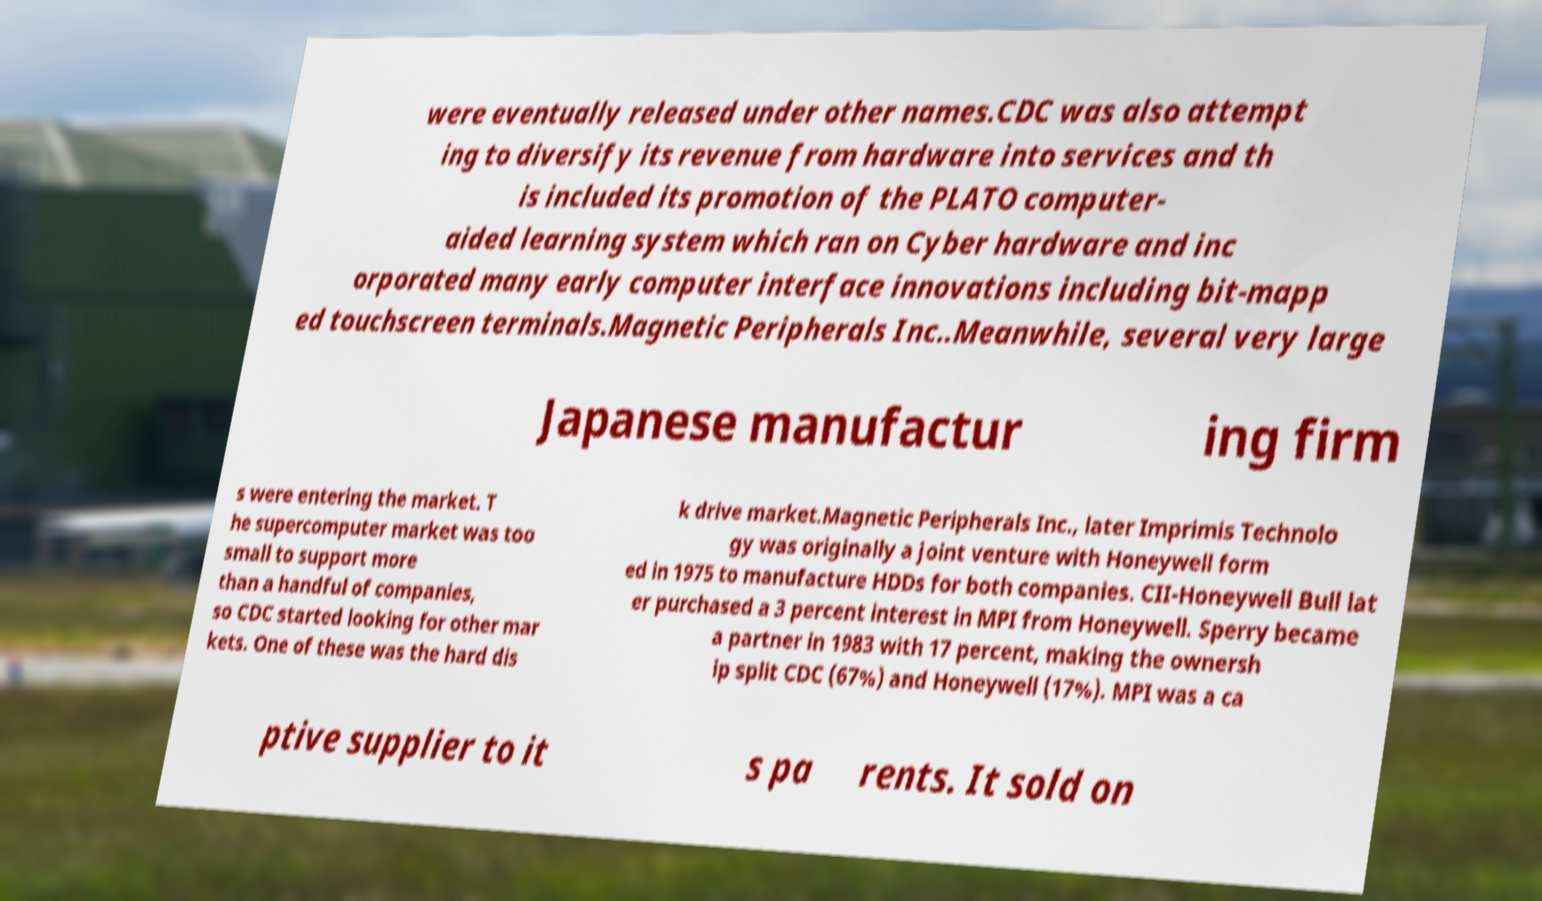Please read and relay the text visible in this image. What does it say? were eventually released under other names.CDC was also attempt ing to diversify its revenue from hardware into services and th is included its promotion of the PLATO computer- aided learning system which ran on Cyber hardware and inc orporated many early computer interface innovations including bit-mapp ed touchscreen terminals.Magnetic Peripherals Inc..Meanwhile, several very large Japanese manufactur ing firm s were entering the market. T he supercomputer market was too small to support more than a handful of companies, so CDC started looking for other mar kets. One of these was the hard dis k drive market.Magnetic Peripherals Inc., later Imprimis Technolo gy was originally a joint venture with Honeywell form ed in 1975 to manufacture HDDs for both companies. CII-Honeywell Bull lat er purchased a 3 percent interest in MPI from Honeywell. Sperry became a partner in 1983 with 17 percent, making the ownersh ip split CDC (67%) and Honeywell (17%). MPI was a ca ptive supplier to it s pa rents. It sold on 